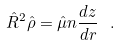Convert formula to latex. <formula><loc_0><loc_0><loc_500><loc_500>\hat { R } ^ { 2 } \hat { \rho } = \hat { \mu } n \frac { d z } { d r } \ .</formula> 